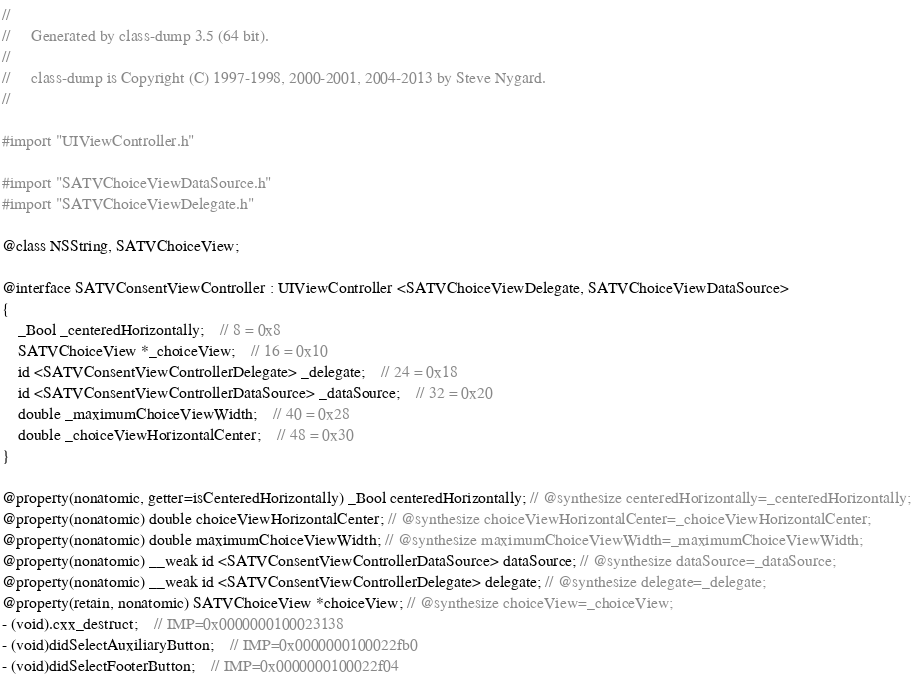Convert code to text. <code><loc_0><loc_0><loc_500><loc_500><_C_>//
//     Generated by class-dump 3.5 (64 bit).
//
//     class-dump is Copyright (C) 1997-1998, 2000-2001, 2004-2013 by Steve Nygard.
//

#import "UIViewController.h"

#import "SATVChoiceViewDataSource.h"
#import "SATVChoiceViewDelegate.h"

@class NSString, SATVChoiceView;

@interface SATVConsentViewController : UIViewController <SATVChoiceViewDelegate, SATVChoiceViewDataSource>
{
    _Bool _centeredHorizontally;	// 8 = 0x8
    SATVChoiceView *_choiceView;	// 16 = 0x10
    id <SATVConsentViewControllerDelegate> _delegate;	// 24 = 0x18
    id <SATVConsentViewControllerDataSource> _dataSource;	// 32 = 0x20
    double _maximumChoiceViewWidth;	// 40 = 0x28
    double _choiceViewHorizontalCenter;	// 48 = 0x30
}

@property(nonatomic, getter=isCenteredHorizontally) _Bool centeredHorizontally; // @synthesize centeredHorizontally=_centeredHorizontally;
@property(nonatomic) double choiceViewHorizontalCenter; // @synthesize choiceViewHorizontalCenter=_choiceViewHorizontalCenter;
@property(nonatomic) double maximumChoiceViewWidth; // @synthesize maximumChoiceViewWidth=_maximumChoiceViewWidth;
@property(nonatomic) __weak id <SATVConsentViewControllerDataSource> dataSource; // @synthesize dataSource=_dataSource;
@property(nonatomic) __weak id <SATVConsentViewControllerDelegate> delegate; // @synthesize delegate=_delegate;
@property(retain, nonatomic) SATVChoiceView *choiceView; // @synthesize choiceView=_choiceView;
- (void).cxx_destruct;	// IMP=0x0000000100023138
- (void)didSelectAuxiliaryButton;	// IMP=0x0000000100022fb0
- (void)didSelectFooterButton;	// IMP=0x0000000100022f04</code> 